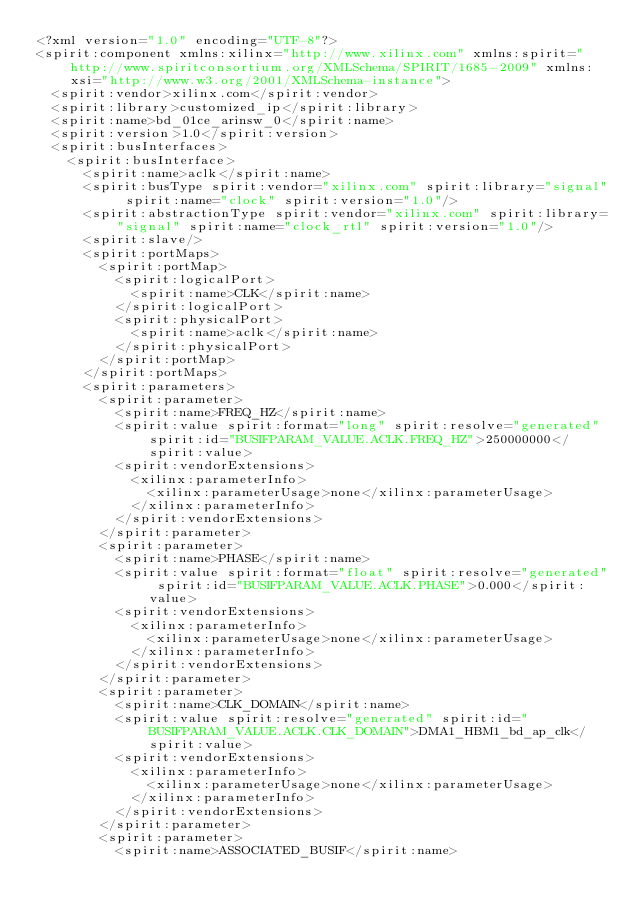Convert code to text. <code><loc_0><loc_0><loc_500><loc_500><_XML_><?xml version="1.0" encoding="UTF-8"?>
<spirit:component xmlns:xilinx="http://www.xilinx.com" xmlns:spirit="http://www.spiritconsortium.org/XMLSchema/SPIRIT/1685-2009" xmlns:xsi="http://www.w3.org/2001/XMLSchema-instance">
  <spirit:vendor>xilinx.com</spirit:vendor>
  <spirit:library>customized_ip</spirit:library>
  <spirit:name>bd_01ce_arinsw_0</spirit:name>
  <spirit:version>1.0</spirit:version>
  <spirit:busInterfaces>
    <spirit:busInterface>
      <spirit:name>aclk</spirit:name>
      <spirit:busType spirit:vendor="xilinx.com" spirit:library="signal" spirit:name="clock" spirit:version="1.0"/>
      <spirit:abstractionType spirit:vendor="xilinx.com" spirit:library="signal" spirit:name="clock_rtl" spirit:version="1.0"/>
      <spirit:slave/>
      <spirit:portMaps>
        <spirit:portMap>
          <spirit:logicalPort>
            <spirit:name>CLK</spirit:name>
          </spirit:logicalPort>
          <spirit:physicalPort>
            <spirit:name>aclk</spirit:name>
          </spirit:physicalPort>
        </spirit:portMap>
      </spirit:portMaps>
      <spirit:parameters>
        <spirit:parameter>
          <spirit:name>FREQ_HZ</spirit:name>
          <spirit:value spirit:format="long" spirit:resolve="generated" spirit:id="BUSIFPARAM_VALUE.ACLK.FREQ_HZ">250000000</spirit:value>
          <spirit:vendorExtensions>
            <xilinx:parameterInfo>
              <xilinx:parameterUsage>none</xilinx:parameterUsage>
            </xilinx:parameterInfo>
          </spirit:vendorExtensions>
        </spirit:parameter>
        <spirit:parameter>
          <spirit:name>PHASE</spirit:name>
          <spirit:value spirit:format="float" spirit:resolve="generated" spirit:id="BUSIFPARAM_VALUE.ACLK.PHASE">0.000</spirit:value>
          <spirit:vendorExtensions>
            <xilinx:parameterInfo>
              <xilinx:parameterUsage>none</xilinx:parameterUsage>
            </xilinx:parameterInfo>
          </spirit:vendorExtensions>
        </spirit:parameter>
        <spirit:parameter>
          <spirit:name>CLK_DOMAIN</spirit:name>
          <spirit:value spirit:resolve="generated" spirit:id="BUSIFPARAM_VALUE.ACLK.CLK_DOMAIN">DMA1_HBM1_bd_ap_clk</spirit:value>
          <spirit:vendorExtensions>
            <xilinx:parameterInfo>
              <xilinx:parameterUsage>none</xilinx:parameterUsage>
            </xilinx:parameterInfo>
          </spirit:vendorExtensions>
        </spirit:parameter>
        <spirit:parameter>
          <spirit:name>ASSOCIATED_BUSIF</spirit:name></code> 